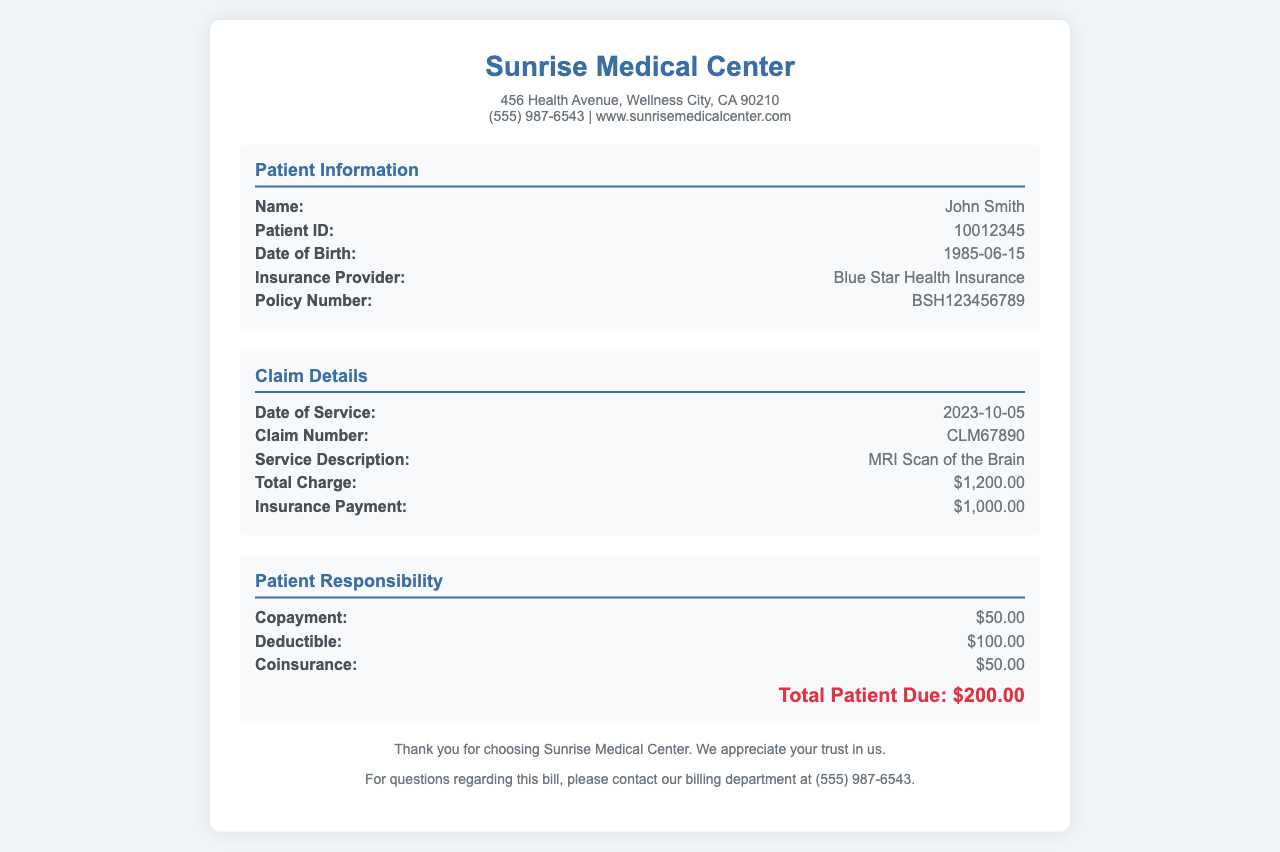What is the patient's name? The patient's name is listed in the Patient Information section of the document.
Answer: John Smith What is the insurance provider? The document specifies the insurance provider for the patient in the Patient Information section.
Answer: Blue Star Health Insurance What is the date of service? The date of service is provided in the Claim Details section of the document.
Answer: 2023-10-05 What is the total charge for the service? The total charge is mentioned in the Claim Details section of the document.
Answer: $1,200.00 How much did the insurance pay? The amount paid by the insurance is outlined in the Claim Details section.
Answer: $1,000.00 What is the copayment amount? The copayment amount is specified in the Patient Responsibility section of the document.
Answer: $50.00 What is the total patient due? The total amount due from the patient is stated at the end of the Patient Responsibility section.
Answer: $200.00 What is the deductible amount? The deductible is included in the Patient Responsibility section of the document.
Answer: $100.00 What is the coinsurance amount? The coinsurance amount is provided in the Patient Responsibility section.
Answer: $50.00 